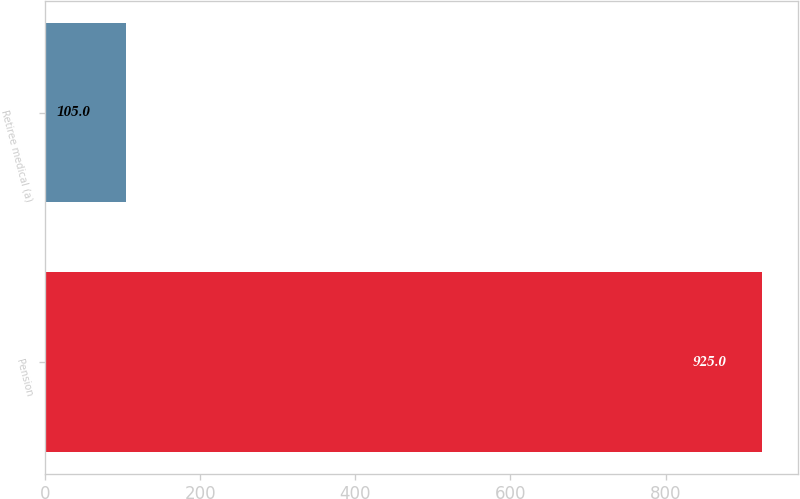Convert chart to OTSL. <chart><loc_0><loc_0><loc_500><loc_500><bar_chart><fcel>Pension<fcel>Retiree medical (a)<nl><fcel>925<fcel>105<nl></chart> 